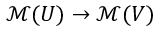Convert formula to latex. <formula><loc_0><loc_0><loc_500><loc_500>{ \mathcal { M } } ( U ) \to { \mathcal { M } } ( V )</formula> 